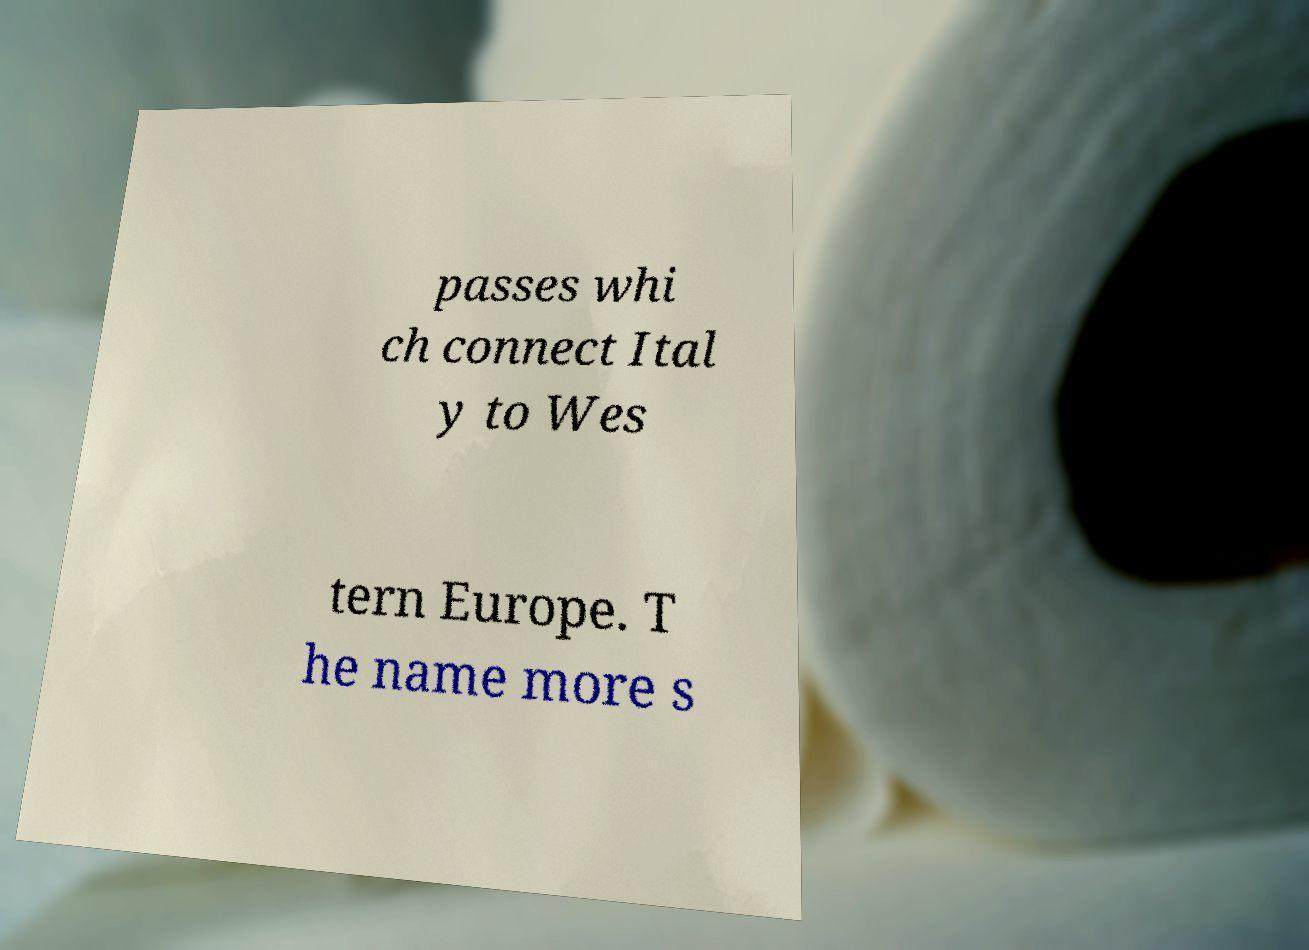What messages or text are displayed in this image? I need them in a readable, typed format. passes whi ch connect Ital y to Wes tern Europe. T he name more s 